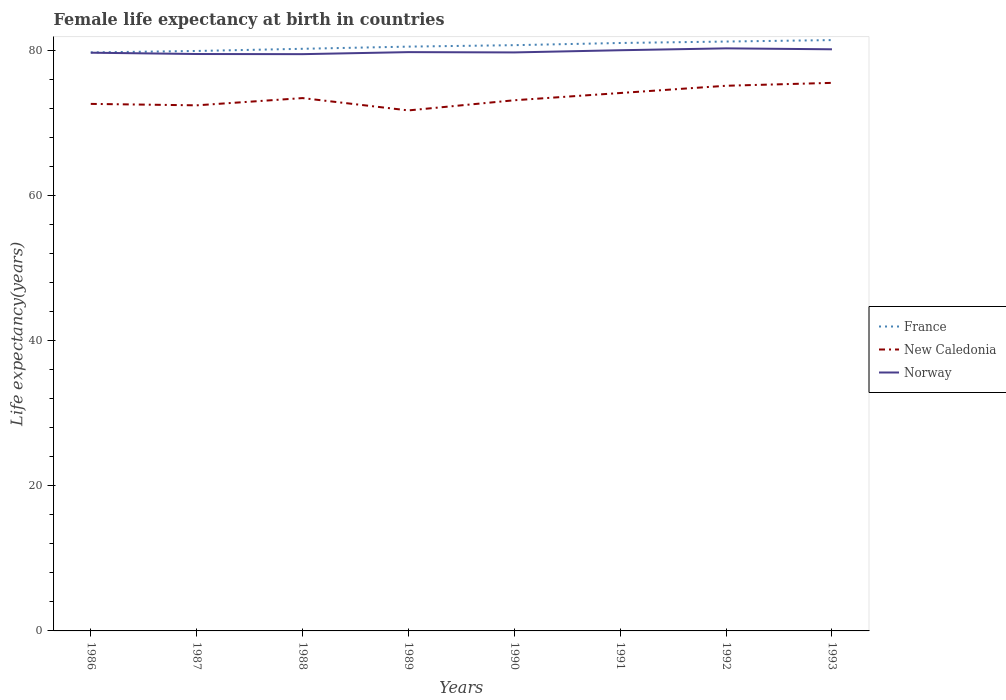Does the line corresponding to Norway intersect with the line corresponding to France?
Your answer should be very brief. No. Across all years, what is the maximum female life expectancy at birth in New Caledonia?
Your answer should be very brief. 71.8. What is the total female life expectancy at birth in Norway in the graph?
Keep it short and to the point. -0.26. What is the difference between the highest and the second highest female life expectancy at birth in Norway?
Your answer should be very brief. 0.8. What is the difference between the highest and the lowest female life expectancy at birth in New Caledonia?
Offer a very short reply. 3. How many lines are there?
Provide a short and direct response. 3. Are the values on the major ticks of Y-axis written in scientific E-notation?
Offer a very short reply. No. How many legend labels are there?
Provide a short and direct response. 3. How are the legend labels stacked?
Ensure brevity in your answer.  Vertical. What is the title of the graph?
Provide a succinct answer. Female life expectancy at birth in countries. Does "Kuwait" appear as one of the legend labels in the graph?
Your response must be concise. No. What is the label or title of the X-axis?
Provide a short and direct response. Years. What is the label or title of the Y-axis?
Your answer should be very brief. Life expectancy(years). What is the Life expectancy(years) of France in 1986?
Provide a short and direct response. 79.8. What is the Life expectancy(years) in New Caledonia in 1986?
Make the answer very short. 72.7. What is the Life expectancy(years) in Norway in 1986?
Your response must be concise. 79.76. What is the Life expectancy(years) in France in 1987?
Keep it short and to the point. 80. What is the Life expectancy(years) of New Caledonia in 1987?
Your answer should be very brief. 72.5. What is the Life expectancy(years) of Norway in 1987?
Offer a very short reply. 79.58. What is the Life expectancy(years) of France in 1988?
Keep it short and to the point. 80.3. What is the Life expectancy(years) of New Caledonia in 1988?
Ensure brevity in your answer.  73.5. What is the Life expectancy(years) in Norway in 1988?
Offer a very short reply. 79.56. What is the Life expectancy(years) in France in 1989?
Your answer should be compact. 80.6. What is the Life expectancy(years) of New Caledonia in 1989?
Ensure brevity in your answer.  71.8. What is the Life expectancy(years) of Norway in 1989?
Ensure brevity in your answer.  79.84. What is the Life expectancy(years) of France in 1990?
Make the answer very short. 80.8. What is the Life expectancy(years) in New Caledonia in 1990?
Your answer should be compact. 73.2. What is the Life expectancy(years) of Norway in 1990?
Provide a succinct answer. 79.8. What is the Life expectancy(years) of France in 1991?
Provide a succinct answer. 81.1. What is the Life expectancy(years) in New Caledonia in 1991?
Provide a succinct answer. 74.2. What is the Life expectancy(years) of Norway in 1991?
Your response must be concise. 80.1. What is the Life expectancy(years) in France in 1992?
Give a very brief answer. 81.3. What is the Life expectancy(years) of New Caledonia in 1992?
Offer a very short reply. 75.2. What is the Life expectancy(years) of Norway in 1992?
Provide a short and direct response. 80.36. What is the Life expectancy(years) of France in 1993?
Ensure brevity in your answer.  81.5. What is the Life expectancy(years) of New Caledonia in 1993?
Offer a very short reply. 75.6. What is the Life expectancy(years) of Norway in 1993?
Provide a short and direct response. 80.23. Across all years, what is the maximum Life expectancy(years) of France?
Your answer should be compact. 81.5. Across all years, what is the maximum Life expectancy(years) in New Caledonia?
Offer a very short reply. 75.6. Across all years, what is the maximum Life expectancy(years) of Norway?
Offer a very short reply. 80.36. Across all years, what is the minimum Life expectancy(years) in France?
Provide a short and direct response. 79.8. Across all years, what is the minimum Life expectancy(years) in New Caledonia?
Offer a terse response. 71.8. Across all years, what is the minimum Life expectancy(years) of Norway?
Give a very brief answer. 79.56. What is the total Life expectancy(years) in France in the graph?
Provide a short and direct response. 645.4. What is the total Life expectancy(years) in New Caledonia in the graph?
Your answer should be compact. 588.7. What is the total Life expectancy(years) of Norway in the graph?
Ensure brevity in your answer.  639.23. What is the difference between the Life expectancy(years) of Norway in 1986 and that in 1987?
Your response must be concise. 0.18. What is the difference between the Life expectancy(years) of France in 1986 and that in 1988?
Provide a short and direct response. -0.5. What is the difference between the Life expectancy(years) in Norway in 1986 and that in 1988?
Make the answer very short. 0.2. What is the difference between the Life expectancy(years) in New Caledonia in 1986 and that in 1989?
Your answer should be compact. 0.9. What is the difference between the Life expectancy(years) of Norway in 1986 and that in 1989?
Your answer should be very brief. -0.08. What is the difference between the Life expectancy(years) of New Caledonia in 1986 and that in 1990?
Your answer should be compact. -0.5. What is the difference between the Life expectancy(years) in Norway in 1986 and that in 1990?
Ensure brevity in your answer.  -0.04. What is the difference between the Life expectancy(years) of New Caledonia in 1986 and that in 1991?
Offer a terse response. -1.5. What is the difference between the Life expectancy(years) of Norway in 1986 and that in 1991?
Provide a short and direct response. -0.34. What is the difference between the Life expectancy(years) in France in 1986 and that in 1992?
Offer a very short reply. -1.5. What is the difference between the Life expectancy(years) in New Caledonia in 1986 and that in 1992?
Give a very brief answer. -2.5. What is the difference between the Life expectancy(years) of Norway in 1986 and that in 1992?
Ensure brevity in your answer.  -0.6. What is the difference between the Life expectancy(years) in France in 1986 and that in 1993?
Offer a terse response. -1.7. What is the difference between the Life expectancy(years) of Norway in 1986 and that in 1993?
Make the answer very short. -0.47. What is the difference between the Life expectancy(years) of France in 1987 and that in 1988?
Your answer should be very brief. -0.3. What is the difference between the Life expectancy(years) in Norway in 1987 and that in 1988?
Offer a terse response. 0.02. What is the difference between the Life expectancy(years) in France in 1987 and that in 1989?
Your answer should be compact. -0.6. What is the difference between the Life expectancy(years) of New Caledonia in 1987 and that in 1989?
Make the answer very short. 0.7. What is the difference between the Life expectancy(years) of Norway in 1987 and that in 1989?
Offer a terse response. -0.26. What is the difference between the Life expectancy(years) of Norway in 1987 and that in 1990?
Give a very brief answer. -0.22. What is the difference between the Life expectancy(years) in New Caledonia in 1987 and that in 1991?
Keep it short and to the point. -1.7. What is the difference between the Life expectancy(years) of Norway in 1987 and that in 1991?
Your response must be concise. -0.52. What is the difference between the Life expectancy(years) in New Caledonia in 1987 and that in 1992?
Offer a terse response. -2.7. What is the difference between the Life expectancy(years) of Norway in 1987 and that in 1992?
Provide a succinct answer. -0.78. What is the difference between the Life expectancy(years) of France in 1987 and that in 1993?
Make the answer very short. -1.5. What is the difference between the Life expectancy(years) in New Caledonia in 1987 and that in 1993?
Your response must be concise. -3.1. What is the difference between the Life expectancy(years) of Norway in 1987 and that in 1993?
Make the answer very short. -0.65. What is the difference between the Life expectancy(years) of France in 1988 and that in 1989?
Provide a short and direct response. -0.3. What is the difference between the Life expectancy(years) of Norway in 1988 and that in 1989?
Make the answer very short. -0.28. What is the difference between the Life expectancy(years) of France in 1988 and that in 1990?
Your answer should be compact. -0.5. What is the difference between the Life expectancy(years) in Norway in 1988 and that in 1990?
Your answer should be compact. -0.24. What is the difference between the Life expectancy(years) in Norway in 1988 and that in 1991?
Keep it short and to the point. -0.54. What is the difference between the Life expectancy(years) in France in 1988 and that in 1992?
Make the answer very short. -1. What is the difference between the Life expectancy(years) in France in 1988 and that in 1993?
Give a very brief answer. -1.2. What is the difference between the Life expectancy(years) in Norway in 1988 and that in 1993?
Your response must be concise. -0.67. What is the difference between the Life expectancy(years) of France in 1989 and that in 1990?
Offer a terse response. -0.2. What is the difference between the Life expectancy(years) in New Caledonia in 1989 and that in 1991?
Make the answer very short. -2.4. What is the difference between the Life expectancy(years) in Norway in 1989 and that in 1991?
Keep it short and to the point. -0.26. What is the difference between the Life expectancy(years) in France in 1989 and that in 1992?
Ensure brevity in your answer.  -0.7. What is the difference between the Life expectancy(years) of Norway in 1989 and that in 1992?
Your answer should be very brief. -0.52. What is the difference between the Life expectancy(years) in New Caledonia in 1989 and that in 1993?
Your answer should be compact. -3.8. What is the difference between the Life expectancy(years) of Norway in 1989 and that in 1993?
Your answer should be compact. -0.39. What is the difference between the Life expectancy(years) of France in 1990 and that in 1991?
Your response must be concise. -0.3. What is the difference between the Life expectancy(years) in New Caledonia in 1990 and that in 1991?
Offer a terse response. -1. What is the difference between the Life expectancy(years) in Norway in 1990 and that in 1991?
Give a very brief answer. -0.3. What is the difference between the Life expectancy(years) in Norway in 1990 and that in 1992?
Provide a short and direct response. -0.56. What is the difference between the Life expectancy(years) in France in 1990 and that in 1993?
Your response must be concise. -0.7. What is the difference between the Life expectancy(years) of New Caledonia in 1990 and that in 1993?
Give a very brief answer. -2.4. What is the difference between the Life expectancy(years) in Norway in 1990 and that in 1993?
Provide a short and direct response. -0.43. What is the difference between the Life expectancy(years) of France in 1991 and that in 1992?
Keep it short and to the point. -0.2. What is the difference between the Life expectancy(years) of Norway in 1991 and that in 1992?
Your answer should be compact. -0.26. What is the difference between the Life expectancy(years) in France in 1991 and that in 1993?
Your answer should be compact. -0.4. What is the difference between the Life expectancy(years) of Norway in 1991 and that in 1993?
Your response must be concise. -0.13. What is the difference between the Life expectancy(years) of France in 1992 and that in 1993?
Make the answer very short. -0.2. What is the difference between the Life expectancy(years) of Norway in 1992 and that in 1993?
Provide a short and direct response. 0.13. What is the difference between the Life expectancy(years) in France in 1986 and the Life expectancy(years) in Norway in 1987?
Make the answer very short. 0.22. What is the difference between the Life expectancy(years) of New Caledonia in 1986 and the Life expectancy(years) of Norway in 1987?
Make the answer very short. -6.88. What is the difference between the Life expectancy(years) of France in 1986 and the Life expectancy(years) of Norway in 1988?
Keep it short and to the point. 0.24. What is the difference between the Life expectancy(years) of New Caledonia in 1986 and the Life expectancy(years) of Norway in 1988?
Give a very brief answer. -6.86. What is the difference between the Life expectancy(years) in France in 1986 and the Life expectancy(years) in Norway in 1989?
Ensure brevity in your answer.  -0.04. What is the difference between the Life expectancy(years) of New Caledonia in 1986 and the Life expectancy(years) of Norway in 1989?
Provide a succinct answer. -7.14. What is the difference between the Life expectancy(years) of France in 1986 and the Life expectancy(years) of New Caledonia in 1990?
Provide a short and direct response. 6.6. What is the difference between the Life expectancy(years) of France in 1986 and the Life expectancy(years) of New Caledonia in 1992?
Provide a short and direct response. 4.6. What is the difference between the Life expectancy(years) of France in 1986 and the Life expectancy(years) of Norway in 1992?
Provide a short and direct response. -0.56. What is the difference between the Life expectancy(years) in New Caledonia in 1986 and the Life expectancy(years) in Norway in 1992?
Provide a short and direct response. -7.66. What is the difference between the Life expectancy(years) of France in 1986 and the Life expectancy(years) of New Caledonia in 1993?
Your answer should be compact. 4.2. What is the difference between the Life expectancy(years) of France in 1986 and the Life expectancy(years) of Norway in 1993?
Your response must be concise. -0.43. What is the difference between the Life expectancy(years) of New Caledonia in 1986 and the Life expectancy(years) of Norway in 1993?
Make the answer very short. -7.53. What is the difference between the Life expectancy(years) of France in 1987 and the Life expectancy(years) of Norway in 1988?
Your answer should be compact. 0.44. What is the difference between the Life expectancy(years) of New Caledonia in 1987 and the Life expectancy(years) of Norway in 1988?
Your answer should be compact. -7.06. What is the difference between the Life expectancy(years) in France in 1987 and the Life expectancy(years) in New Caledonia in 1989?
Make the answer very short. 8.2. What is the difference between the Life expectancy(years) of France in 1987 and the Life expectancy(years) of Norway in 1989?
Make the answer very short. 0.16. What is the difference between the Life expectancy(years) in New Caledonia in 1987 and the Life expectancy(years) in Norway in 1989?
Ensure brevity in your answer.  -7.34. What is the difference between the Life expectancy(years) of France in 1987 and the Life expectancy(years) of Norway in 1990?
Your response must be concise. 0.2. What is the difference between the Life expectancy(years) of New Caledonia in 1987 and the Life expectancy(years) of Norway in 1990?
Your answer should be very brief. -7.3. What is the difference between the Life expectancy(years) of France in 1987 and the Life expectancy(years) of Norway in 1991?
Provide a short and direct response. -0.1. What is the difference between the Life expectancy(years) in France in 1987 and the Life expectancy(years) in Norway in 1992?
Offer a very short reply. -0.36. What is the difference between the Life expectancy(years) in New Caledonia in 1987 and the Life expectancy(years) in Norway in 1992?
Offer a very short reply. -7.86. What is the difference between the Life expectancy(years) in France in 1987 and the Life expectancy(years) in Norway in 1993?
Ensure brevity in your answer.  -0.23. What is the difference between the Life expectancy(years) of New Caledonia in 1987 and the Life expectancy(years) of Norway in 1993?
Make the answer very short. -7.73. What is the difference between the Life expectancy(years) in France in 1988 and the Life expectancy(years) in Norway in 1989?
Offer a very short reply. 0.46. What is the difference between the Life expectancy(years) in New Caledonia in 1988 and the Life expectancy(years) in Norway in 1989?
Your response must be concise. -6.34. What is the difference between the Life expectancy(years) of France in 1988 and the Life expectancy(years) of New Caledonia in 1990?
Your answer should be very brief. 7.1. What is the difference between the Life expectancy(years) of France in 1988 and the Life expectancy(years) of Norway in 1990?
Provide a short and direct response. 0.5. What is the difference between the Life expectancy(years) in France in 1988 and the Life expectancy(years) in Norway in 1991?
Provide a succinct answer. 0.2. What is the difference between the Life expectancy(years) in New Caledonia in 1988 and the Life expectancy(years) in Norway in 1991?
Keep it short and to the point. -6.6. What is the difference between the Life expectancy(years) in France in 1988 and the Life expectancy(years) in New Caledonia in 1992?
Ensure brevity in your answer.  5.1. What is the difference between the Life expectancy(years) in France in 1988 and the Life expectancy(years) in Norway in 1992?
Your answer should be very brief. -0.06. What is the difference between the Life expectancy(years) of New Caledonia in 1988 and the Life expectancy(years) of Norway in 1992?
Ensure brevity in your answer.  -6.86. What is the difference between the Life expectancy(years) of France in 1988 and the Life expectancy(years) of New Caledonia in 1993?
Your answer should be compact. 4.7. What is the difference between the Life expectancy(years) in France in 1988 and the Life expectancy(years) in Norway in 1993?
Provide a short and direct response. 0.07. What is the difference between the Life expectancy(years) in New Caledonia in 1988 and the Life expectancy(years) in Norway in 1993?
Offer a very short reply. -6.73. What is the difference between the Life expectancy(years) of France in 1989 and the Life expectancy(years) of Norway in 1990?
Offer a very short reply. 0.8. What is the difference between the Life expectancy(years) in New Caledonia in 1989 and the Life expectancy(years) in Norway in 1990?
Offer a terse response. -8. What is the difference between the Life expectancy(years) in France in 1989 and the Life expectancy(years) in New Caledonia in 1991?
Your answer should be compact. 6.4. What is the difference between the Life expectancy(years) of New Caledonia in 1989 and the Life expectancy(years) of Norway in 1991?
Offer a terse response. -8.3. What is the difference between the Life expectancy(years) in France in 1989 and the Life expectancy(years) in Norway in 1992?
Give a very brief answer. 0.24. What is the difference between the Life expectancy(years) in New Caledonia in 1989 and the Life expectancy(years) in Norway in 1992?
Offer a very short reply. -8.56. What is the difference between the Life expectancy(years) of France in 1989 and the Life expectancy(years) of Norway in 1993?
Your answer should be very brief. 0.37. What is the difference between the Life expectancy(years) in New Caledonia in 1989 and the Life expectancy(years) in Norway in 1993?
Your answer should be compact. -8.43. What is the difference between the Life expectancy(years) of France in 1990 and the Life expectancy(years) of Norway in 1991?
Provide a short and direct response. 0.7. What is the difference between the Life expectancy(years) of France in 1990 and the Life expectancy(years) of Norway in 1992?
Offer a terse response. 0.44. What is the difference between the Life expectancy(years) of New Caledonia in 1990 and the Life expectancy(years) of Norway in 1992?
Ensure brevity in your answer.  -7.16. What is the difference between the Life expectancy(years) in France in 1990 and the Life expectancy(years) in New Caledonia in 1993?
Give a very brief answer. 5.2. What is the difference between the Life expectancy(years) in France in 1990 and the Life expectancy(years) in Norway in 1993?
Your answer should be compact. 0.57. What is the difference between the Life expectancy(years) of New Caledonia in 1990 and the Life expectancy(years) of Norway in 1993?
Provide a succinct answer. -7.03. What is the difference between the Life expectancy(years) of France in 1991 and the Life expectancy(years) of New Caledonia in 1992?
Offer a terse response. 5.9. What is the difference between the Life expectancy(years) in France in 1991 and the Life expectancy(years) in Norway in 1992?
Your response must be concise. 0.74. What is the difference between the Life expectancy(years) in New Caledonia in 1991 and the Life expectancy(years) in Norway in 1992?
Ensure brevity in your answer.  -6.16. What is the difference between the Life expectancy(years) of France in 1991 and the Life expectancy(years) of New Caledonia in 1993?
Ensure brevity in your answer.  5.5. What is the difference between the Life expectancy(years) of France in 1991 and the Life expectancy(years) of Norway in 1993?
Make the answer very short. 0.87. What is the difference between the Life expectancy(years) in New Caledonia in 1991 and the Life expectancy(years) in Norway in 1993?
Give a very brief answer. -6.03. What is the difference between the Life expectancy(years) in France in 1992 and the Life expectancy(years) in New Caledonia in 1993?
Ensure brevity in your answer.  5.7. What is the difference between the Life expectancy(years) of France in 1992 and the Life expectancy(years) of Norway in 1993?
Ensure brevity in your answer.  1.07. What is the difference between the Life expectancy(years) of New Caledonia in 1992 and the Life expectancy(years) of Norway in 1993?
Keep it short and to the point. -5.03. What is the average Life expectancy(years) of France per year?
Ensure brevity in your answer.  80.67. What is the average Life expectancy(years) in New Caledonia per year?
Provide a succinct answer. 73.59. What is the average Life expectancy(years) of Norway per year?
Provide a succinct answer. 79.9. In the year 1986, what is the difference between the Life expectancy(years) of France and Life expectancy(years) of Norway?
Keep it short and to the point. 0.04. In the year 1986, what is the difference between the Life expectancy(years) in New Caledonia and Life expectancy(years) in Norway?
Make the answer very short. -7.06. In the year 1987, what is the difference between the Life expectancy(years) in France and Life expectancy(years) in Norway?
Give a very brief answer. 0.42. In the year 1987, what is the difference between the Life expectancy(years) in New Caledonia and Life expectancy(years) in Norway?
Make the answer very short. -7.08. In the year 1988, what is the difference between the Life expectancy(years) of France and Life expectancy(years) of Norway?
Your answer should be very brief. 0.74. In the year 1988, what is the difference between the Life expectancy(years) in New Caledonia and Life expectancy(years) in Norway?
Your response must be concise. -6.06. In the year 1989, what is the difference between the Life expectancy(years) in France and Life expectancy(years) in New Caledonia?
Keep it short and to the point. 8.8. In the year 1989, what is the difference between the Life expectancy(years) of France and Life expectancy(years) of Norway?
Your answer should be very brief. 0.76. In the year 1989, what is the difference between the Life expectancy(years) in New Caledonia and Life expectancy(years) in Norway?
Provide a short and direct response. -8.04. In the year 1990, what is the difference between the Life expectancy(years) of France and Life expectancy(years) of New Caledonia?
Offer a very short reply. 7.6. In the year 1990, what is the difference between the Life expectancy(years) of New Caledonia and Life expectancy(years) of Norway?
Make the answer very short. -6.6. In the year 1991, what is the difference between the Life expectancy(years) in France and Life expectancy(years) in New Caledonia?
Keep it short and to the point. 6.9. In the year 1992, what is the difference between the Life expectancy(years) in France and Life expectancy(years) in Norway?
Give a very brief answer. 0.94. In the year 1992, what is the difference between the Life expectancy(years) in New Caledonia and Life expectancy(years) in Norway?
Provide a succinct answer. -5.16. In the year 1993, what is the difference between the Life expectancy(years) in France and Life expectancy(years) in New Caledonia?
Keep it short and to the point. 5.9. In the year 1993, what is the difference between the Life expectancy(years) in France and Life expectancy(years) in Norway?
Provide a short and direct response. 1.27. In the year 1993, what is the difference between the Life expectancy(years) in New Caledonia and Life expectancy(years) in Norway?
Make the answer very short. -4.63. What is the ratio of the Life expectancy(years) of France in 1986 to that in 1987?
Keep it short and to the point. 1. What is the ratio of the Life expectancy(years) of New Caledonia in 1986 to that in 1987?
Provide a short and direct response. 1. What is the ratio of the Life expectancy(years) in Norway in 1986 to that in 1988?
Keep it short and to the point. 1. What is the ratio of the Life expectancy(years) of New Caledonia in 1986 to that in 1989?
Keep it short and to the point. 1.01. What is the ratio of the Life expectancy(years) of Norway in 1986 to that in 1989?
Keep it short and to the point. 1. What is the ratio of the Life expectancy(years) of France in 1986 to that in 1990?
Make the answer very short. 0.99. What is the ratio of the Life expectancy(years) in New Caledonia in 1986 to that in 1991?
Provide a short and direct response. 0.98. What is the ratio of the Life expectancy(years) of France in 1986 to that in 1992?
Keep it short and to the point. 0.98. What is the ratio of the Life expectancy(years) of New Caledonia in 1986 to that in 1992?
Make the answer very short. 0.97. What is the ratio of the Life expectancy(years) in Norway in 1986 to that in 1992?
Ensure brevity in your answer.  0.99. What is the ratio of the Life expectancy(years) in France in 1986 to that in 1993?
Provide a short and direct response. 0.98. What is the ratio of the Life expectancy(years) in New Caledonia in 1986 to that in 1993?
Ensure brevity in your answer.  0.96. What is the ratio of the Life expectancy(years) in France in 1987 to that in 1988?
Your response must be concise. 1. What is the ratio of the Life expectancy(years) in New Caledonia in 1987 to that in 1988?
Offer a very short reply. 0.99. What is the ratio of the Life expectancy(years) of France in 1987 to that in 1989?
Provide a short and direct response. 0.99. What is the ratio of the Life expectancy(years) in New Caledonia in 1987 to that in 1989?
Offer a very short reply. 1.01. What is the ratio of the Life expectancy(years) of France in 1987 to that in 1990?
Offer a very short reply. 0.99. What is the ratio of the Life expectancy(years) of New Caledonia in 1987 to that in 1990?
Provide a succinct answer. 0.99. What is the ratio of the Life expectancy(years) of France in 1987 to that in 1991?
Give a very brief answer. 0.99. What is the ratio of the Life expectancy(years) of New Caledonia in 1987 to that in 1991?
Offer a terse response. 0.98. What is the ratio of the Life expectancy(years) of Norway in 1987 to that in 1991?
Ensure brevity in your answer.  0.99. What is the ratio of the Life expectancy(years) of New Caledonia in 1987 to that in 1992?
Provide a short and direct response. 0.96. What is the ratio of the Life expectancy(years) in Norway in 1987 to that in 1992?
Your answer should be compact. 0.99. What is the ratio of the Life expectancy(years) of France in 1987 to that in 1993?
Your answer should be compact. 0.98. What is the ratio of the Life expectancy(years) of New Caledonia in 1987 to that in 1993?
Provide a short and direct response. 0.96. What is the ratio of the Life expectancy(years) of New Caledonia in 1988 to that in 1989?
Your answer should be very brief. 1.02. What is the ratio of the Life expectancy(years) in Norway in 1988 to that in 1989?
Give a very brief answer. 1. What is the ratio of the Life expectancy(years) in France in 1988 to that in 1990?
Make the answer very short. 0.99. What is the ratio of the Life expectancy(years) of New Caledonia in 1988 to that in 1990?
Give a very brief answer. 1. What is the ratio of the Life expectancy(years) in France in 1988 to that in 1991?
Provide a succinct answer. 0.99. What is the ratio of the Life expectancy(years) of New Caledonia in 1988 to that in 1991?
Your answer should be compact. 0.99. What is the ratio of the Life expectancy(years) of New Caledonia in 1988 to that in 1992?
Provide a short and direct response. 0.98. What is the ratio of the Life expectancy(years) of Norway in 1988 to that in 1992?
Provide a short and direct response. 0.99. What is the ratio of the Life expectancy(years) of France in 1988 to that in 1993?
Provide a short and direct response. 0.99. What is the ratio of the Life expectancy(years) of New Caledonia in 1988 to that in 1993?
Ensure brevity in your answer.  0.97. What is the ratio of the Life expectancy(years) in New Caledonia in 1989 to that in 1990?
Provide a short and direct response. 0.98. What is the ratio of the Life expectancy(years) in France in 1989 to that in 1991?
Give a very brief answer. 0.99. What is the ratio of the Life expectancy(years) in New Caledonia in 1989 to that in 1991?
Give a very brief answer. 0.97. What is the ratio of the Life expectancy(years) of New Caledonia in 1989 to that in 1992?
Your answer should be compact. 0.95. What is the ratio of the Life expectancy(years) of Norway in 1989 to that in 1992?
Ensure brevity in your answer.  0.99. What is the ratio of the Life expectancy(years) in France in 1989 to that in 1993?
Your response must be concise. 0.99. What is the ratio of the Life expectancy(years) of New Caledonia in 1989 to that in 1993?
Keep it short and to the point. 0.95. What is the ratio of the Life expectancy(years) in Norway in 1989 to that in 1993?
Keep it short and to the point. 1. What is the ratio of the Life expectancy(years) of New Caledonia in 1990 to that in 1991?
Your response must be concise. 0.99. What is the ratio of the Life expectancy(years) in Norway in 1990 to that in 1991?
Ensure brevity in your answer.  1. What is the ratio of the Life expectancy(years) in New Caledonia in 1990 to that in 1992?
Make the answer very short. 0.97. What is the ratio of the Life expectancy(years) of France in 1990 to that in 1993?
Make the answer very short. 0.99. What is the ratio of the Life expectancy(years) in New Caledonia in 1990 to that in 1993?
Ensure brevity in your answer.  0.97. What is the ratio of the Life expectancy(years) in France in 1991 to that in 1992?
Your response must be concise. 1. What is the ratio of the Life expectancy(years) of New Caledonia in 1991 to that in 1992?
Your answer should be compact. 0.99. What is the ratio of the Life expectancy(years) in France in 1991 to that in 1993?
Ensure brevity in your answer.  1. What is the ratio of the Life expectancy(years) in New Caledonia in 1991 to that in 1993?
Give a very brief answer. 0.98. What is the difference between the highest and the second highest Life expectancy(years) of Norway?
Provide a short and direct response. 0.13. What is the difference between the highest and the lowest Life expectancy(years) in France?
Ensure brevity in your answer.  1.7. 